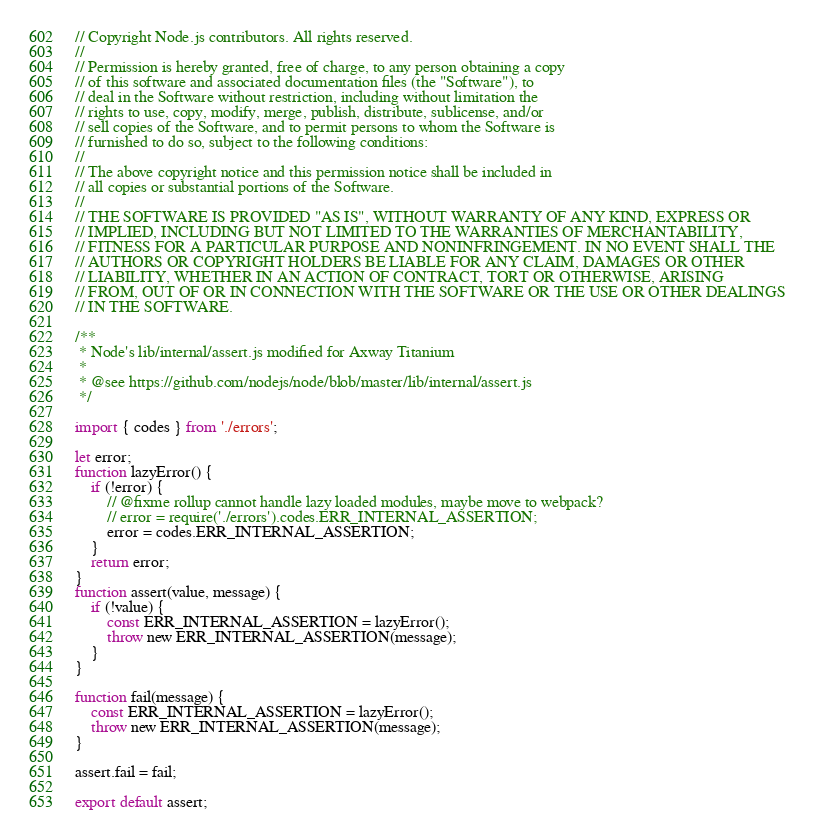<code> <loc_0><loc_0><loc_500><loc_500><_JavaScript_>// Copyright Node.js contributors. All rights reserved.
//
// Permission is hereby granted, free of charge, to any person obtaining a copy
// of this software and associated documentation files (the "Software"), to
// deal in the Software without restriction, including without limitation the
// rights to use, copy, modify, merge, publish, distribute, sublicense, and/or
// sell copies of the Software, and to permit persons to whom the Software is
// furnished to do so, subject to the following conditions:
//
// The above copyright notice and this permission notice shall be included in
// all copies or substantial portions of the Software.
//
// THE SOFTWARE IS PROVIDED "AS IS", WITHOUT WARRANTY OF ANY KIND, EXPRESS OR
// IMPLIED, INCLUDING BUT NOT LIMITED TO THE WARRANTIES OF MERCHANTABILITY,
// FITNESS FOR A PARTICULAR PURPOSE AND NONINFRINGEMENT. IN NO EVENT SHALL THE
// AUTHORS OR COPYRIGHT HOLDERS BE LIABLE FOR ANY CLAIM, DAMAGES OR OTHER
// LIABILITY, WHETHER IN AN ACTION OF CONTRACT, TORT OR OTHERWISE, ARISING
// FROM, OUT OF OR IN CONNECTION WITH THE SOFTWARE OR THE USE OR OTHER DEALINGS
// IN THE SOFTWARE.

/**
 * Node's lib/internal/assert.js modified for Axway Titanium
 *
 * @see https://github.com/nodejs/node/blob/master/lib/internal/assert.js
 */

import { codes } from './errors';

let error;
function lazyError() {
	if (!error) {
		// @fixme rollup cannot handle lazy loaded modules, maybe move to webpack?
		// error = require('./errors').codes.ERR_INTERNAL_ASSERTION;
		error = codes.ERR_INTERNAL_ASSERTION;
	}
	return error;
}
function assert(value, message) {
	if (!value) {
		const ERR_INTERNAL_ASSERTION = lazyError();
		throw new ERR_INTERNAL_ASSERTION(message);
	}
}

function fail(message) {
	const ERR_INTERNAL_ASSERTION = lazyError();
	throw new ERR_INTERNAL_ASSERTION(message);
}

assert.fail = fail;

export default assert;
</code> 